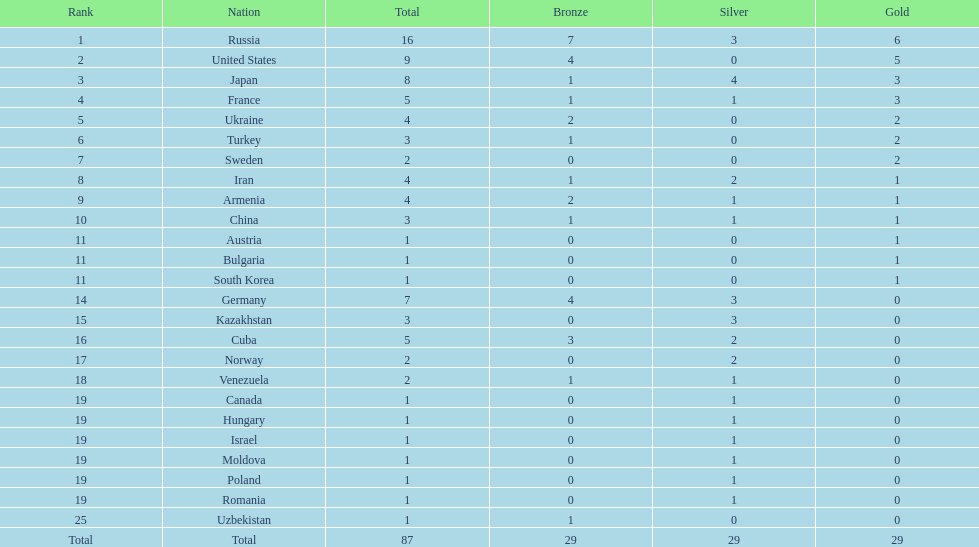Who ranked right after turkey? Sweden. 